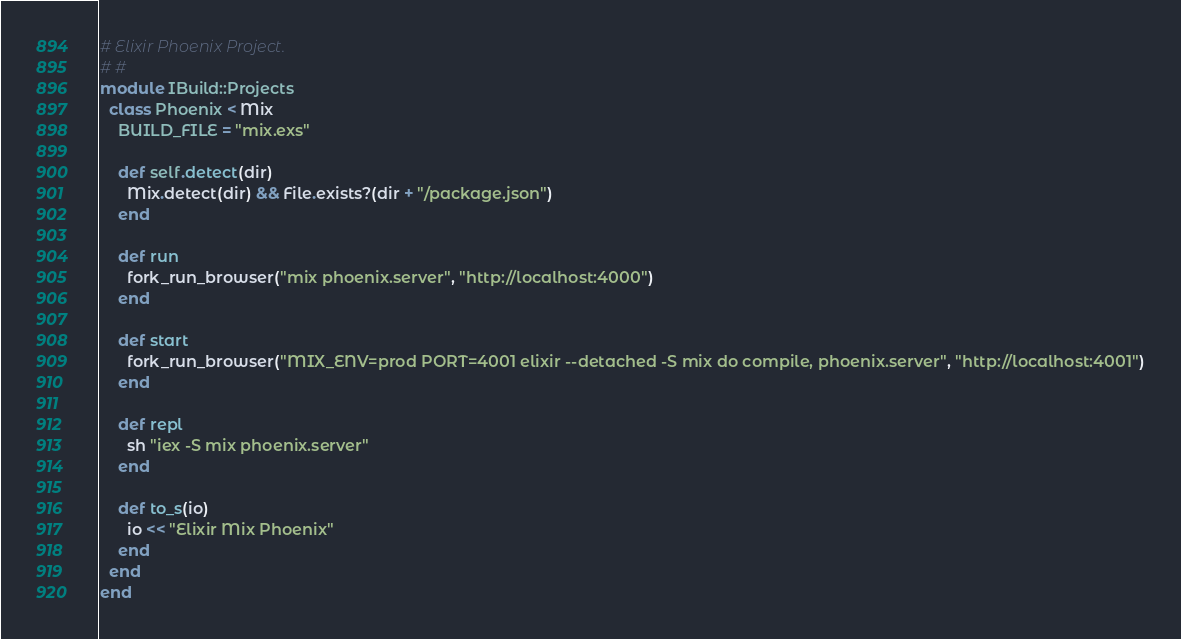Convert code to text. <code><loc_0><loc_0><loc_500><loc_500><_Crystal_># Elixir Phoenix Project.
# #
module IBuild::Projects
  class Phoenix < Mix
    BUILD_FILE = "mix.exs"

    def self.detect(dir)
      Mix.detect(dir) && File.exists?(dir + "/package.json")
    end

    def run
      fork_run_browser("mix phoenix.server", "http://localhost:4000")
    end

    def start
      fork_run_browser("MIX_ENV=prod PORT=4001 elixir --detached -S mix do compile, phoenix.server", "http://localhost:4001")
    end

    def repl
      sh "iex -S mix phoenix.server"
    end

    def to_s(io)
      io << "Elixir Mix Phoenix"
    end
  end
end
</code> 